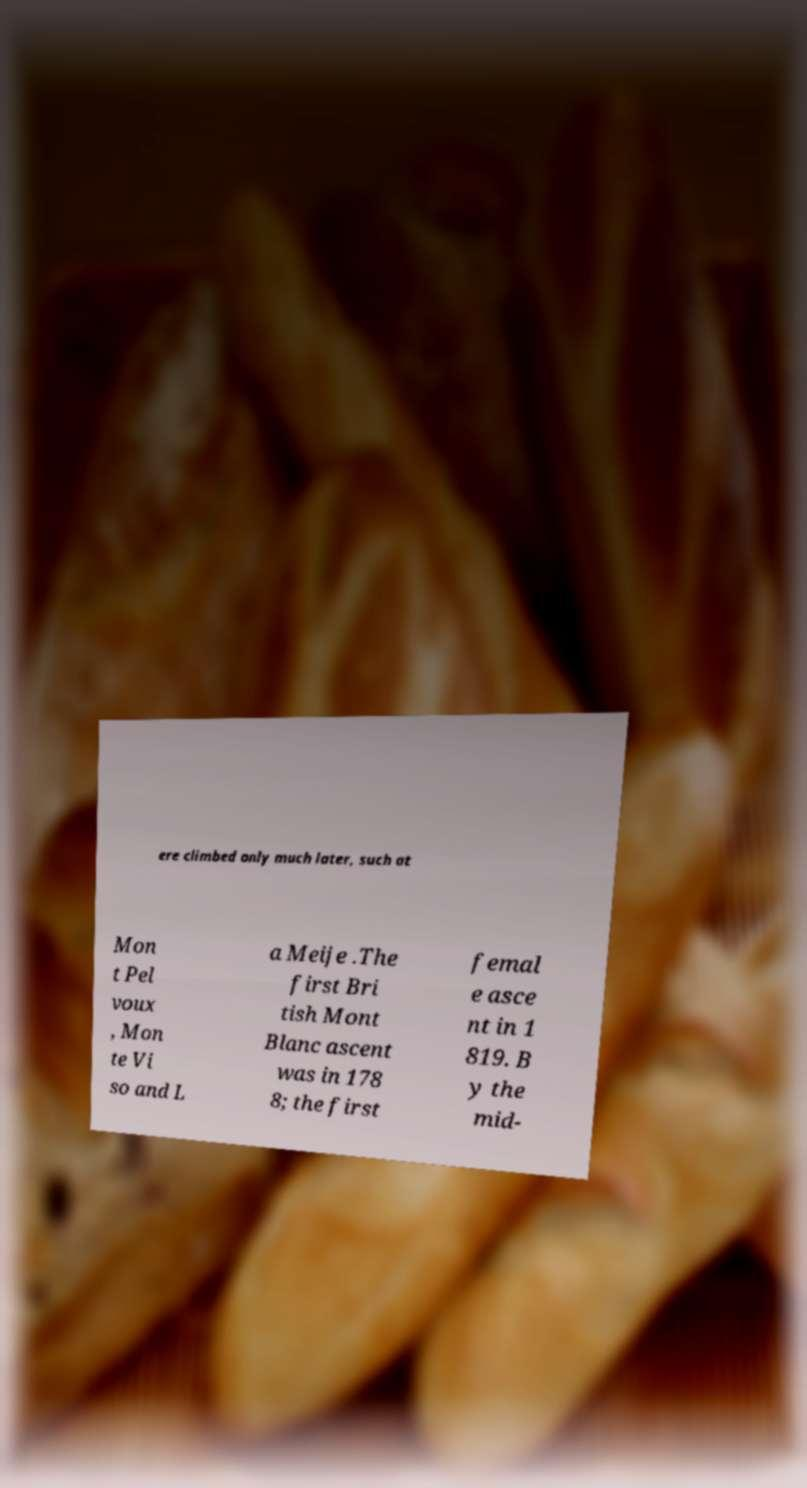I need the written content from this picture converted into text. Can you do that? ere climbed only much later, such at Mon t Pel voux , Mon te Vi so and L a Meije .The first Bri tish Mont Blanc ascent was in 178 8; the first femal e asce nt in 1 819. B y the mid- 